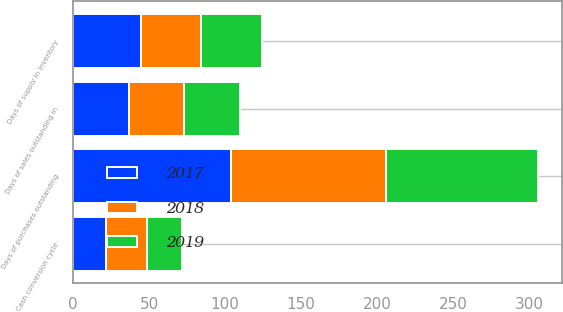<chart> <loc_0><loc_0><loc_500><loc_500><stacked_bar_chart><ecel><fcel>Days of sales outstanding in<fcel>Days of supply in inventory<fcel>Days of purchases outstanding<fcel>Cash conversion cycle<nl><fcel>2017<fcel>37<fcel>45<fcel>104<fcel>22<nl><fcel>2019<fcel>37<fcel>40<fcel>100<fcel>23<nl><fcel>2018<fcel>36<fcel>39<fcel>102<fcel>27<nl></chart> 